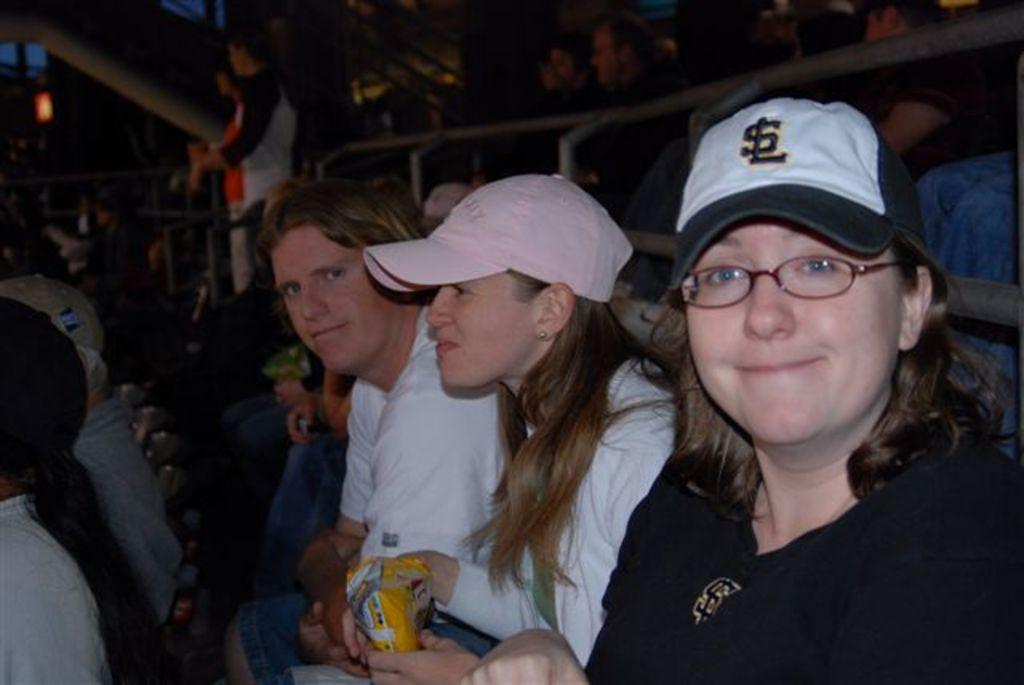What are the people in the image doing? There are groups of people sitting on chairs in the image. Can you describe the person who is not sitting in the image? There is a person standing in the image. What kind of structure can be seen in the image? There is a barricade-like structure in the image. What can be seen in the background of the image? There is a light visible in the background of the image. What type of dinosaurs can be seen roaming around in the image? There are no dinosaurs present in the image. What kind of fowl is sitting on the person's shoulder in the image? There is no fowl present in the image. 